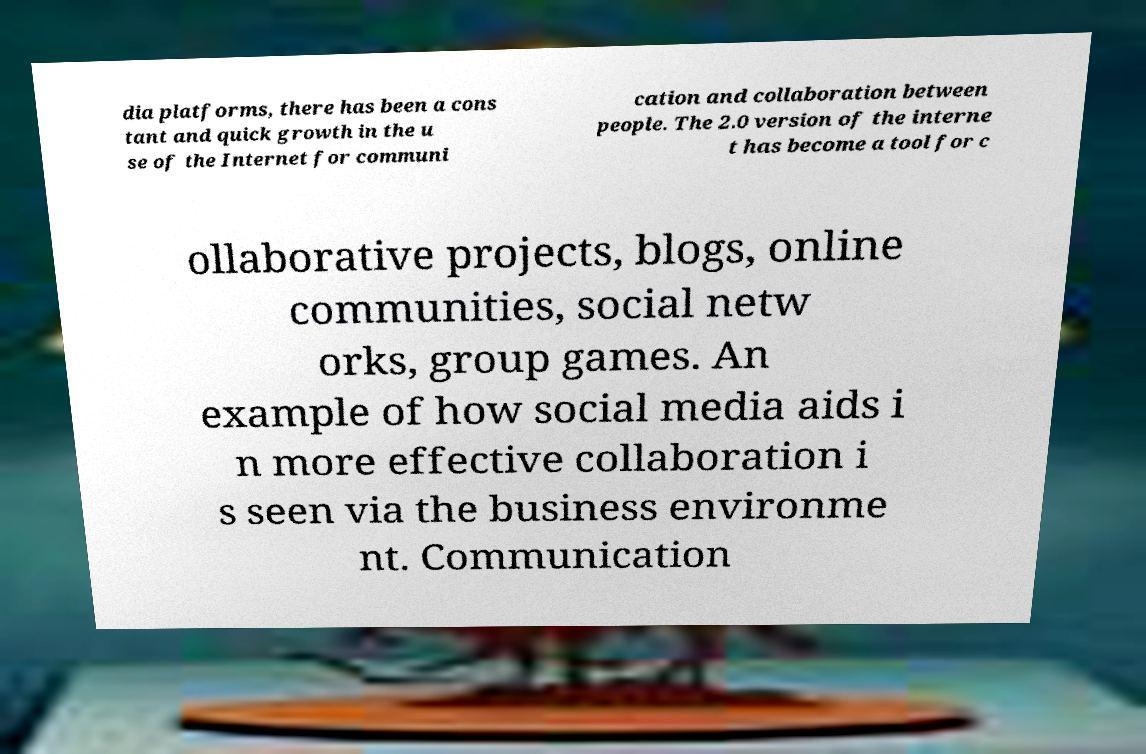For documentation purposes, I need the text within this image transcribed. Could you provide that? dia platforms, there has been a cons tant and quick growth in the u se of the Internet for communi cation and collaboration between people. The 2.0 version of the interne t has become a tool for c ollaborative projects, blogs, online communities, social netw orks, group games. An example of how social media aids i n more effective collaboration i s seen via the business environme nt. Communication 